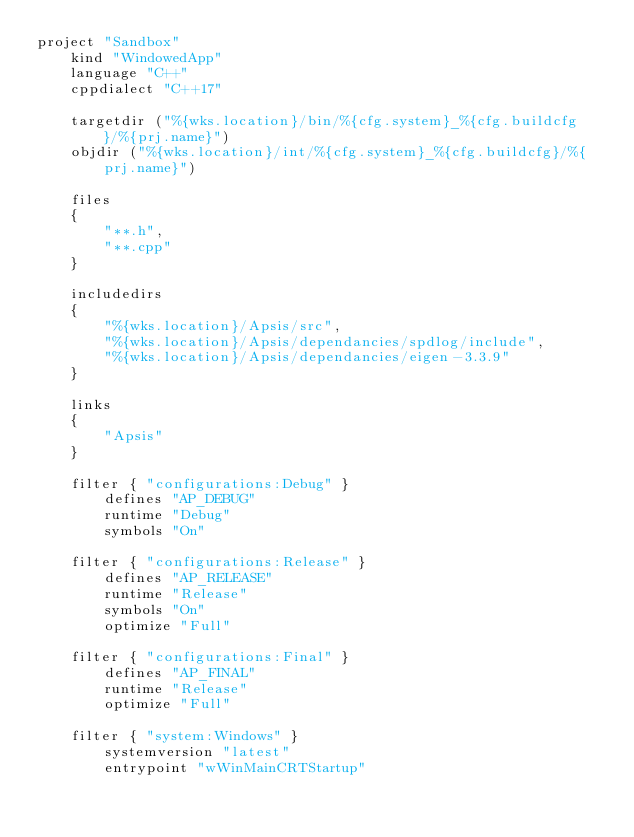Convert code to text. <code><loc_0><loc_0><loc_500><loc_500><_Lua_>project "Sandbox"
	kind "WindowedApp"
	language "C++"
	cppdialect "C++17"

	targetdir ("%{wks.location}/bin/%{cfg.system}_%{cfg.buildcfg}/%{prj.name}")
	objdir ("%{wks.location}/int/%{cfg.system}_%{cfg.buildcfg}/%{prj.name}")

	files
	{
		"**.h",
		"**.cpp"
	}

	includedirs
	{
		"%{wks.location}/Apsis/src",
		"%{wks.location}/Apsis/dependancies/spdlog/include",
		"%{wks.location}/Apsis/dependancies/eigen-3.3.9"
	}

	links
	{
		"Apsis"
	}

	filter { "configurations:Debug" }
		defines "AP_DEBUG"
		runtime "Debug"
		symbols "On"

	filter { "configurations:Release" }
		defines "AP_RELEASE"
		runtime "Release"
		symbols "On"
		optimize "Full"

	filter { "configurations:Final" }
		defines "AP_FINAL"
		runtime "Release"
		optimize "Full"

	filter { "system:Windows" }
		systemversion "latest"
		entrypoint "wWinMainCRTStartup"</code> 